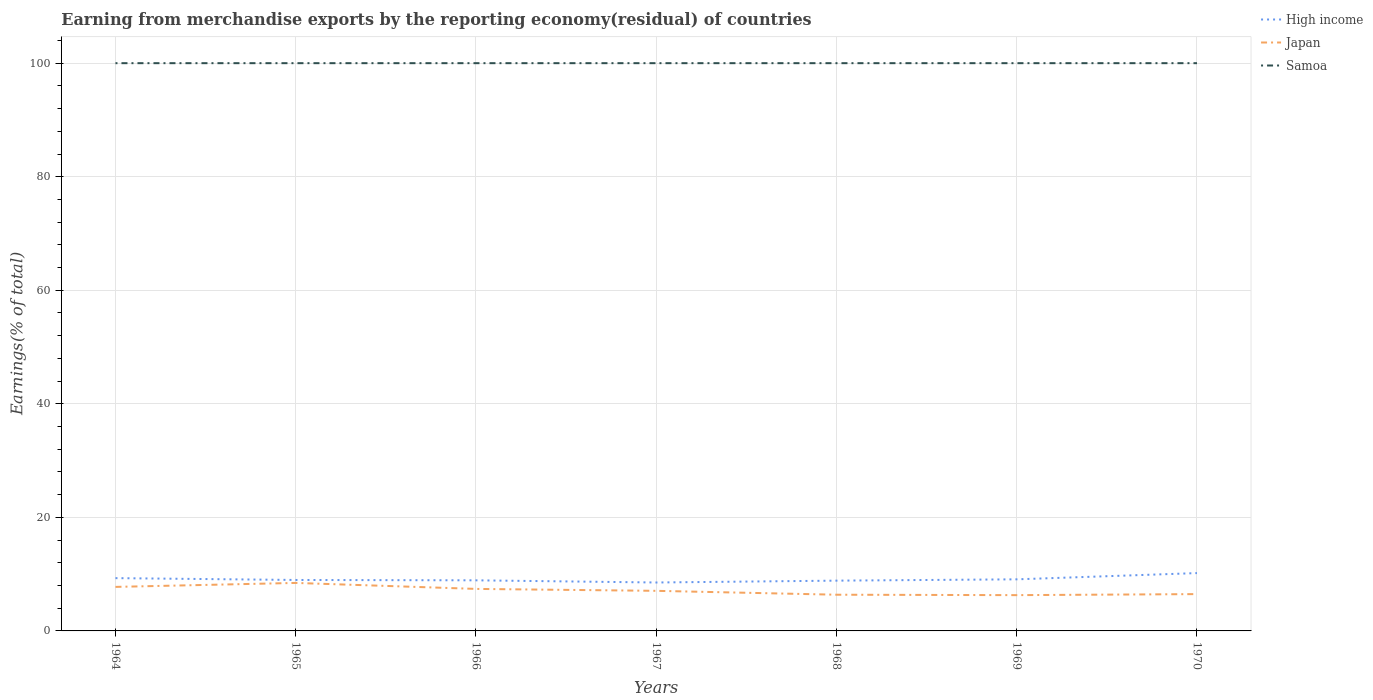How many different coloured lines are there?
Provide a short and direct response. 3. Is the number of lines equal to the number of legend labels?
Your answer should be compact. Yes. In which year was the percentage of amount earned from merchandise exports in Japan maximum?
Provide a succinct answer. 1969. What is the total percentage of amount earned from merchandise exports in High income in the graph?
Provide a succinct answer. -1.27. How many lines are there?
Provide a short and direct response. 3. Are the values on the major ticks of Y-axis written in scientific E-notation?
Ensure brevity in your answer.  No. Does the graph contain any zero values?
Provide a succinct answer. No. How are the legend labels stacked?
Make the answer very short. Vertical. What is the title of the graph?
Keep it short and to the point. Earning from merchandise exports by the reporting economy(residual) of countries. Does "Tunisia" appear as one of the legend labels in the graph?
Your answer should be very brief. No. What is the label or title of the Y-axis?
Provide a succinct answer. Earnings(% of total). What is the Earnings(% of total) of High income in 1964?
Give a very brief answer. 9.3. What is the Earnings(% of total) of Japan in 1964?
Your answer should be compact. 7.75. What is the Earnings(% of total) in High income in 1965?
Give a very brief answer. 8.97. What is the Earnings(% of total) of Japan in 1965?
Provide a succinct answer. 8.45. What is the Earnings(% of total) in High income in 1966?
Offer a very short reply. 8.91. What is the Earnings(% of total) of Japan in 1966?
Keep it short and to the point. 7.4. What is the Earnings(% of total) of Samoa in 1966?
Give a very brief answer. 100. What is the Earnings(% of total) in High income in 1967?
Your response must be concise. 8.53. What is the Earnings(% of total) of Japan in 1967?
Keep it short and to the point. 7.06. What is the Earnings(% of total) of Samoa in 1967?
Ensure brevity in your answer.  100. What is the Earnings(% of total) in High income in 1968?
Your response must be concise. 8.86. What is the Earnings(% of total) in Japan in 1968?
Offer a very short reply. 6.38. What is the Earnings(% of total) of Samoa in 1968?
Give a very brief answer. 100. What is the Earnings(% of total) of High income in 1969?
Ensure brevity in your answer.  9.09. What is the Earnings(% of total) of Japan in 1969?
Offer a very short reply. 6.3. What is the Earnings(% of total) in Samoa in 1969?
Your answer should be compact. 100. What is the Earnings(% of total) of High income in 1970?
Provide a succinct answer. 10.19. What is the Earnings(% of total) in Japan in 1970?
Ensure brevity in your answer.  6.48. What is the Earnings(% of total) of Samoa in 1970?
Your answer should be very brief. 100. Across all years, what is the maximum Earnings(% of total) in High income?
Offer a terse response. 10.19. Across all years, what is the maximum Earnings(% of total) in Japan?
Offer a very short reply. 8.45. Across all years, what is the maximum Earnings(% of total) in Samoa?
Your response must be concise. 100. Across all years, what is the minimum Earnings(% of total) of High income?
Your answer should be very brief. 8.53. Across all years, what is the minimum Earnings(% of total) of Japan?
Provide a short and direct response. 6.3. Across all years, what is the minimum Earnings(% of total) of Samoa?
Offer a terse response. 100. What is the total Earnings(% of total) of High income in the graph?
Offer a terse response. 63.85. What is the total Earnings(% of total) in Japan in the graph?
Provide a short and direct response. 49.83. What is the total Earnings(% of total) of Samoa in the graph?
Your answer should be very brief. 700. What is the difference between the Earnings(% of total) of High income in 1964 and that in 1965?
Make the answer very short. 0.32. What is the difference between the Earnings(% of total) of Japan in 1964 and that in 1965?
Offer a terse response. -0.7. What is the difference between the Earnings(% of total) in High income in 1964 and that in 1966?
Make the answer very short. 0.39. What is the difference between the Earnings(% of total) in Japan in 1964 and that in 1966?
Your response must be concise. 0.35. What is the difference between the Earnings(% of total) of High income in 1964 and that in 1967?
Make the answer very short. 0.77. What is the difference between the Earnings(% of total) in Japan in 1964 and that in 1967?
Keep it short and to the point. 0.69. What is the difference between the Earnings(% of total) in High income in 1964 and that in 1968?
Provide a succinct answer. 0.44. What is the difference between the Earnings(% of total) of Japan in 1964 and that in 1968?
Ensure brevity in your answer.  1.38. What is the difference between the Earnings(% of total) in Samoa in 1964 and that in 1968?
Keep it short and to the point. 0. What is the difference between the Earnings(% of total) of High income in 1964 and that in 1969?
Provide a short and direct response. 0.21. What is the difference between the Earnings(% of total) in Japan in 1964 and that in 1969?
Your answer should be compact. 1.45. What is the difference between the Earnings(% of total) of Samoa in 1964 and that in 1969?
Make the answer very short. 0. What is the difference between the Earnings(% of total) of High income in 1964 and that in 1970?
Keep it short and to the point. -0.89. What is the difference between the Earnings(% of total) in Japan in 1964 and that in 1970?
Your response must be concise. 1.27. What is the difference between the Earnings(% of total) of Samoa in 1964 and that in 1970?
Make the answer very short. 0. What is the difference between the Earnings(% of total) in High income in 1965 and that in 1966?
Provide a short and direct response. 0.06. What is the difference between the Earnings(% of total) of Japan in 1965 and that in 1966?
Give a very brief answer. 1.05. What is the difference between the Earnings(% of total) in High income in 1965 and that in 1967?
Your answer should be very brief. 0.45. What is the difference between the Earnings(% of total) of Japan in 1965 and that in 1967?
Give a very brief answer. 1.39. What is the difference between the Earnings(% of total) of Samoa in 1965 and that in 1967?
Your answer should be compact. 0. What is the difference between the Earnings(% of total) of High income in 1965 and that in 1968?
Make the answer very short. 0.12. What is the difference between the Earnings(% of total) in Japan in 1965 and that in 1968?
Ensure brevity in your answer.  2.08. What is the difference between the Earnings(% of total) in High income in 1965 and that in 1969?
Keep it short and to the point. -0.11. What is the difference between the Earnings(% of total) of Japan in 1965 and that in 1969?
Offer a terse response. 2.15. What is the difference between the Earnings(% of total) of High income in 1965 and that in 1970?
Your answer should be compact. -1.21. What is the difference between the Earnings(% of total) of Japan in 1965 and that in 1970?
Offer a very short reply. 1.97. What is the difference between the Earnings(% of total) of Samoa in 1965 and that in 1970?
Provide a succinct answer. 0. What is the difference between the Earnings(% of total) of High income in 1966 and that in 1967?
Your response must be concise. 0.38. What is the difference between the Earnings(% of total) of Japan in 1966 and that in 1967?
Ensure brevity in your answer.  0.34. What is the difference between the Earnings(% of total) in High income in 1966 and that in 1968?
Your answer should be compact. 0.06. What is the difference between the Earnings(% of total) in Japan in 1966 and that in 1968?
Give a very brief answer. 1.02. What is the difference between the Earnings(% of total) in High income in 1966 and that in 1969?
Keep it short and to the point. -0.17. What is the difference between the Earnings(% of total) in Japan in 1966 and that in 1969?
Offer a terse response. 1.1. What is the difference between the Earnings(% of total) of Samoa in 1966 and that in 1969?
Offer a terse response. 0. What is the difference between the Earnings(% of total) in High income in 1966 and that in 1970?
Your response must be concise. -1.27. What is the difference between the Earnings(% of total) of Japan in 1966 and that in 1970?
Your answer should be very brief. 0.92. What is the difference between the Earnings(% of total) of High income in 1967 and that in 1968?
Your answer should be very brief. -0.33. What is the difference between the Earnings(% of total) in Japan in 1967 and that in 1968?
Make the answer very short. 0.68. What is the difference between the Earnings(% of total) of Samoa in 1967 and that in 1968?
Offer a terse response. 0. What is the difference between the Earnings(% of total) of High income in 1967 and that in 1969?
Your answer should be compact. -0.56. What is the difference between the Earnings(% of total) in Japan in 1967 and that in 1969?
Offer a terse response. 0.76. What is the difference between the Earnings(% of total) in Samoa in 1967 and that in 1969?
Offer a very short reply. 0. What is the difference between the Earnings(% of total) of High income in 1967 and that in 1970?
Offer a terse response. -1.66. What is the difference between the Earnings(% of total) of Japan in 1967 and that in 1970?
Make the answer very short. 0.58. What is the difference between the Earnings(% of total) in High income in 1968 and that in 1969?
Ensure brevity in your answer.  -0.23. What is the difference between the Earnings(% of total) of Japan in 1968 and that in 1969?
Provide a short and direct response. 0.07. What is the difference between the Earnings(% of total) in Samoa in 1968 and that in 1969?
Offer a terse response. 0. What is the difference between the Earnings(% of total) in High income in 1968 and that in 1970?
Provide a short and direct response. -1.33. What is the difference between the Earnings(% of total) in Japan in 1968 and that in 1970?
Your answer should be very brief. -0.11. What is the difference between the Earnings(% of total) in Samoa in 1968 and that in 1970?
Keep it short and to the point. 0. What is the difference between the Earnings(% of total) of High income in 1969 and that in 1970?
Your response must be concise. -1.1. What is the difference between the Earnings(% of total) in Japan in 1969 and that in 1970?
Your answer should be very brief. -0.18. What is the difference between the Earnings(% of total) of Samoa in 1969 and that in 1970?
Make the answer very short. 0. What is the difference between the Earnings(% of total) of High income in 1964 and the Earnings(% of total) of Japan in 1965?
Make the answer very short. 0.84. What is the difference between the Earnings(% of total) in High income in 1964 and the Earnings(% of total) in Samoa in 1965?
Provide a short and direct response. -90.7. What is the difference between the Earnings(% of total) in Japan in 1964 and the Earnings(% of total) in Samoa in 1965?
Your response must be concise. -92.25. What is the difference between the Earnings(% of total) of High income in 1964 and the Earnings(% of total) of Japan in 1966?
Provide a short and direct response. 1.9. What is the difference between the Earnings(% of total) of High income in 1964 and the Earnings(% of total) of Samoa in 1966?
Offer a very short reply. -90.7. What is the difference between the Earnings(% of total) in Japan in 1964 and the Earnings(% of total) in Samoa in 1966?
Provide a short and direct response. -92.25. What is the difference between the Earnings(% of total) in High income in 1964 and the Earnings(% of total) in Japan in 1967?
Offer a very short reply. 2.24. What is the difference between the Earnings(% of total) in High income in 1964 and the Earnings(% of total) in Samoa in 1967?
Make the answer very short. -90.7. What is the difference between the Earnings(% of total) of Japan in 1964 and the Earnings(% of total) of Samoa in 1967?
Your answer should be compact. -92.25. What is the difference between the Earnings(% of total) of High income in 1964 and the Earnings(% of total) of Japan in 1968?
Offer a terse response. 2.92. What is the difference between the Earnings(% of total) in High income in 1964 and the Earnings(% of total) in Samoa in 1968?
Keep it short and to the point. -90.7. What is the difference between the Earnings(% of total) in Japan in 1964 and the Earnings(% of total) in Samoa in 1968?
Offer a terse response. -92.25. What is the difference between the Earnings(% of total) in High income in 1964 and the Earnings(% of total) in Japan in 1969?
Provide a short and direct response. 3. What is the difference between the Earnings(% of total) in High income in 1964 and the Earnings(% of total) in Samoa in 1969?
Ensure brevity in your answer.  -90.7. What is the difference between the Earnings(% of total) of Japan in 1964 and the Earnings(% of total) of Samoa in 1969?
Make the answer very short. -92.25. What is the difference between the Earnings(% of total) of High income in 1964 and the Earnings(% of total) of Japan in 1970?
Keep it short and to the point. 2.81. What is the difference between the Earnings(% of total) in High income in 1964 and the Earnings(% of total) in Samoa in 1970?
Make the answer very short. -90.7. What is the difference between the Earnings(% of total) of Japan in 1964 and the Earnings(% of total) of Samoa in 1970?
Your answer should be very brief. -92.25. What is the difference between the Earnings(% of total) in High income in 1965 and the Earnings(% of total) in Japan in 1966?
Keep it short and to the point. 1.57. What is the difference between the Earnings(% of total) of High income in 1965 and the Earnings(% of total) of Samoa in 1966?
Provide a short and direct response. -91.03. What is the difference between the Earnings(% of total) in Japan in 1965 and the Earnings(% of total) in Samoa in 1966?
Keep it short and to the point. -91.55. What is the difference between the Earnings(% of total) in High income in 1965 and the Earnings(% of total) in Japan in 1967?
Your response must be concise. 1.91. What is the difference between the Earnings(% of total) of High income in 1965 and the Earnings(% of total) of Samoa in 1967?
Your answer should be compact. -91.03. What is the difference between the Earnings(% of total) in Japan in 1965 and the Earnings(% of total) in Samoa in 1967?
Make the answer very short. -91.55. What is the difference between the Earnings(% of total) in High income in 1965 and the Earnings(% of total) in Japan in 1968?
Offer a terse response. 2.6. What is the difference between the Earnings(% of total) of High income in 1965 and the Earnings(% of total) of Samoa in 1968?
Make the answer very short. -91.03. What is the difference between the Earnings(% of total) in Japan in 1965 and the Earnings(% of total) in Samoa in 1968?
Give a very brief answer. -91.55. What is the difference between the Earnings(% of total) of High income in 1965 and the Earnings(% of total) of Japan in 1969?
Give a very brief answer. 2.67. What is the difference between the Earnings(% of total) of High income in 1965 and the Earnings(% of total) of Samoa in 1969?
Offer a terse response. -91.03. What is the difference between the Earnings(% of total) in Japan in 1965 and the Earnings(% of total) in Samoa in 1969?
Offer a terse response. -91.55. What is the difference between the Earnings(% of total) in High income in 1965 and the Earnings(% of total) in Japan in 1970?
Ensure brevity in your answer.  2.49. What is the difference between the Earnings(% of total) in High income in 1965 and the Earnings(% of total) in Samoa in 1970?
Your answer should be very brief. -91.03. What is the difference between the Earnings(% of total) in Japan in 1965 and the Earnings(% of total) in Samoa in 1970?
Your response must be concise. -91.55. What is the difference between the Earnings(% of total) of High income in 1966 and the Earnings(% of total) of Japan in 1967?
Keep it short and to the point. 1.85. What is the difference between the Earnings(% of total) of High income in 1966 and the Earnings(% of total) of Samoa in 1967?
Keep it short and to the point. -91.09. What is the difference between the Earnings(% of total) of Japan in 1966 and the Earnings(% of total) of Samoa in 1967?
Keep it short and to the point. -92.6. What is the difference between the Earnings(% of total) of High income in 1966 and the Earnings(% of total) of Japan in 1968?
Provide a succinct answer. 2.54. What is the difference between the Earnings(% of total) of High income in 1966 and the Earnings(% of total) of Samoa in 1968?
Give a very brief answer. -91.09. What is the difference between the Earnings(% of total) in Japan in 1966 and the Earnings(% of total) in Samoa in 1968?
Offer a terse response. -92.6. What is the difference between the Earnings(% of total) in High income in 1966 and the Earnings(% of total) in Japan in 1969?
Your response must be concise. 2.61. What is the difference between the Earnings(% of total) in High income in 1966 and the Earnings(% of total) in Samoa in 1969?
Offer a very short reply. -91.09. What is the difference between the Earnings(% of total) in Japan in 1966 and the Earnings(% of total) in Samoa in 1969?
Your answer should be very brief. -92.6. What is the difference between the Earnings(% of total) in High income in 1966 and the Earnings(% of total) in Japan in 1970?
Provide a succinct answer. 2.43. What is the difference between the Earnings(% of total) of High income in 1966 and the Earnings(% of total) of Samoa in 1970?
Provide a succinct answer. -91.09. What is the difference between the Earnings(% of total) in Japan in 1966 and the Earnings(% of total) in Samoa in 1970?
Make the answer very short. -92.6. What is the difference between the Earnings(% of total) in High income in 1967 and the Earnings(% of total) in Japan in 1968?
Your response must be concise. 2.15. What is the difference between the Earnings(% of total) of High income in 1967 and the Earnings(% of total) of Samoa in 1968?
Your answer should be very brief. -91.47. What is the difference between the Earnings(% of total) of Japan in 1967 and the Earnings(% of total) of Samoa in 1968?
Give a very brief answer. -92.94. What is the difference between the Earnings(% of total) of High income in 1967 and the Earnings(% of total) of Japan in 1969?
Your answer should be very brief. 2.23. What is the difference between the Earnings(% of total) in High income in 1967 and the Earnings(% of total) in Samoa in 1969?
Provide a succinct answer. -91.47. What is the difference between the Earnings(% of total) of Japan in 1967 and the Earnings(% of total) of Samoa in 1969?
Provide a short and direct response. -92.94. What is the difference between the Earnings(% of total) in High income in 1967 and the Earnings(% of total) in Japan in 1970?
Keep it short and to the point. 2.05. What is the difference between the Earnings(% of total) in High income in 1967 and the Earnings(% of total) in Samoa in 1970?
Offer a terse response. -91.47. What is the difference between the Earnings(% of total) of Japan in 1967 and the Earnings(% of total) of Samoa in 1970?
Your answer should be very brief. -92.94. What is the difference between the Earnings(% of total) of High income in 1968 and the Earnings(% of total) of Japan in 1969?
Your answer should be compact. 2.55. What is the difference between the Earnings(% of total) of High income in 1968 and the Earnings(% of total) of Samoa in 1969?
Make the answer very short. -91.14. What is the difference between the Earnings(% of total) in Japan in 1968 and the Earnings(% of total) in Samoa in 1969?
Your response must be concise. -93.62. What is the difference between the Earnings(% of total) in High income in 1968 and the Earnings(% of total) in Japan in 1970?
Your answer should be compact. 2.37. What is the difference between the Earnings(% of total) of High income in 1968 and the Earnings(% of total) of Samoa in 1970?
Offer a terse response. -91.14. What is the difference between the Earnings(% of total) in Japan in 1968 and the Earnings(% of total) in Samoa in 1970?
Offer a terse response. -93.62. What is the difference between the Earnings(% of total) in High income in 1969 and the Earnings(% of total) in Japan in 1970?
Offer a very short reply. 2.6. What is the difference between the Earnings(% of total) of High income in 1969 and the Earnings(% of total) of Samoa in 1970?
Keep it short and to the point. -90.91. What is the difference between the Earnings(% of total) in Japan in 1969 and the Earnings(% of total) in Samoa in 1970?
Ensure brevity in your answer.  -93.7. What is the average Earnings(% of total) in High income per year?
Provide a succinct answer. 9.12. What is the average Earnings(% of total) in Japan per year?
Your response must be concise. 7.12. What is the average Earnings(% of total) in Samoa per year?
Your answer should be compact. 100. In the year 1964, what is the difference between the Earnings(% of total) in High income and Earnings(% of total) in Japan?
Your response must be concise. 1.54. In the year 1964, what is the difference between the Earnings(% of total) of High income and Earnings(% of total) of Samoa?
Ensure brevity in your answer.  -90.7. In the year 1964, what is the difference between the Earnings(% of total) of Japan and Earnings(% of total) of Samoa?
Ensure brevity in your answer.  -92.25. In the year 1965, what is the difference between the Earnings(% of total) in High income and Earnings(% of total) in Japan?
Offer a very short reply. 0.52. In the year 1965, what is the difference between the Earnings(% of total) of High income and Earnings(% of total) of Samoa?
Provide a succinct answer. -91.03. In the year 1965, what is the difference between the Earnings(% of total) in Japan and Earnings(% of total) in Samoa?
Provide a succinct answer. -91.55. In the year 1966, what is the difference between the Earnings(% of total) of High income and Earnings(% of total) of Japan?
Give a very brief answer. 1.51. In the year 1966, what is the difference between the Earnings(% of total) of High income and Earnings(% of total) of Samoa?
Your answer should be compact. -91.09. In the year 1966, what is the difference between the Earnings(% of total) of Japan and Earnings(% of total) of Samoa?
Provide a succinct answer. -92.6. In the year 1967, what is the difference between the Earnings(% of total) of High income and Earnings(% of total) of Japan?
Give a very brief answer. 1.47. In the year 1967, what is the difference between the Earnings(% of total) in High income and Earnings(% of total) in Samoa?
Provide a short and direct response. -91.47. In the year 1967, what is the difference between the Earnings(% of total) of Japan and Earnings(% of total) of Samoa?
Ensure brevity in your answer.  -92.94. In the year 1968, what is the difference between the Earnings(% of total) in High income and Earnings(% of total) in Japan?
Your answer should be compact. 2.48. In the year 1968, what is the difference between the Earnings(% of total) of High income and Earnings(% of total) of Samoa?
Provide a succinct answer. -91.14. In the year 1968, what is the difference between the Earnings(% of total) in Japan and Earnings(% of total) in Samoa?
Ensure brevity in your answer.  -93.62. In the year 1969, what is the difference between the Earnings(% of total) in High income and Earnings(% of total) in Japan?
Offer a terse response. 2.78. In the year 1969, what is the difference between the Earnings(% of total) in High income and Earnings(% of total) in Samoa?
Offer a terse response. -90.91. In the year 1969, what is the difference between the Earnings(% of total) of Japan and Earnings(% of total) of Samoa?
Give a very brief answer. -93.7. In the year 1970, what is the difference between the Earnings(% of total) in High income and Earnings(% of total) in Japan?
Provide a succinct answer. 3.7. In the year 1970, what is the difference between the Earnings(% of total) of High income and Earnings(% of total) of Samoa?
Offer a very short reply. -89.81. In the year 1970, what is the difference between the Earnings(% of total) in Japan and Earnings(% of total) in Samoa?
Offer a very short reply. -93.52. What is the ratio of the Earnings(% of total) in High income in 1964 to that in 1965?
Provide a succinct answer. 1.04. What is the ratio of the Earnings(% of total) of Japan in 1964 to that in 1965?
Your response must be concise. 0.92. What is the ratio of the Earnings(% of total) in High income in 1964 to that in 1966?
Provide a succinct answer. 1.04. What is the ratio of the Earnings(% of total) in Japan in 1964 to that in 1966?
Your answer should be compact. 1.05. What is the ratio of the Earnings(% of total) in Samoa in 1964 to that in 1966?
Give a very brief answer. 1. What is the ratio of the Earnings(% of total) in High income in 1964 to that in 1967?
Offer a very short reply. 1.09. What is the ratio of the Earnings(% of total) of Japan in 1964 to that in 1967?
Provide a succinct answer. 1.1. What is the ratio of the Earnings(% of total) of Samoa in 1964 to that in 1967?
Make the answer very short. 1. What is the ratio of the Earnings(% of total) in Japan in 1964 to that in 1968?
Ensure brevity in your answer.  1.22. What is the ratio of the Earnings(% of total) of High income in 1964 to that in 1969?
Offer a very short reply. 1.02. What is the ratio of the Earnings(% of total) in Japan in 1964 to that in 1969?
Provide a succinct answer. 1.23. What is the ratio of the Earnings(% of total) in High income in 1964 to that in 1970?
Provide a succinct answer. 0.91. What is the ratio of the Earnings(% of total) of Japan in 1964 to that in 1970?
Your answer should be compact. 1.2. What is the ratio of the Earnings(% of total) in Samoa in 1964 to that in 1970?
Your answer should be compact. 1. What is the ratio of the Earnings(% of total) of Japan in 1965 to that in 1966?
Provide a succinct answer. 1.14. What is the ratio of the Earnings(% of total) of High income in 1965 to that in 1967?
Offer a terse response. 1.05. What is the ratio of the Earnings(% of total) in Japan in 1965 to that in 1967?
Give a very brief answer. 1.2. What is the ratio of the Earnings(% of total) of High income in 1965 to that in 1968?
Offer a very short reply. 1.01. What is the ratio of the Earnings(% of total) in Japan in 1965 to that in 1968?
Ensure brevity in your answer.  1.33. What is the ratio of the Earnings(% of total) of Samoa in 1965 to that in 1968?
Give a very brief answer. 1. What is the ratio of the Earnings(% of total) in Japan in 1965 to that in 1969?
Give a very brief answer. 1.34. What is the ratio of the Earnings(% of total) of Samoa in 1965 to that in 1969?
Keep it short and to the point. 1. What is the ratio of the Earnings(% of total) of High income in 1965 to that in 1970?
Offer a very short reply. 0.88. What is the ratio of the Earnings(% of total) in Japan in 1965 to that in 1970?
Make the answer very short. 1.3. What is the ratio of the Earnings(% of total) in Samoa in 1965 to that in 1970?
Offer a terse response. 1. What is the ratio of the Earnings(% of total) of High income in 1966 to that in 1967?
Keep it short and to the point. 1.04. What is the ratio of the Earnings(% of total) in Japan in 1966 to that in 1967?
Offer a terse response. 1.05. What is the ratio of the Earnings(% of total) of Samoa in 1966 to that in 1967?
Make the answer very short. 1. What is the ratio of the Earnings(% of total) in High income in 1966 to that in 1968?
Provide a succinct answer. 1.01. What is the ratio of the Earnings(% of total) of Japan in 1966 to that in 1968?
Keep it short and to the point. 1.16. What is the ratio of the Earnings(% of total) of High income in 1966 to that in 1969?
Offer a terse response. 0.98. What is the ratio of the Earnings(% of total) of Japan in 1966 to that in 1969?
Your answer should be compact. 1.17. What is the ratio of the Earnings(% of total) in Samoa in 1966 to that in 1969?
Ensure brevity in your answer.  1. What is the ratio of the Earnings(% of total) of High income in 1966 to that in 1970?
Your answer should be compact. 0.87. What is the ratio of the Earnings(% of total) in Japan in 1966 to that in 1970?
Your answer should be compact. 1.14. What is the ratio of the Earnings(% of total) of High income in 1967 to that in 1968?
Your answer should be compact. 0.96. What is the ratio of the Earnings(% of total) of Japan in 1967 to that in 1968?
Provide a short and direct response. 1.11. What is the ratio of the Earnings(% of total) of Samoa in 1967 to that in 1968?
Offer a very short reply. 1. What is the ratio of the Earnings(% of total) in High income in 1967 to that in 1969?
Keep it short and to the point. 0.94. What is the ratio of the Earnings(% of total) of Japan in 1967 to that in 1969?
Your answer should be very brief. 1.12. What is the ratio of the Earnings(% of total) of High income in 1967 to that in 1970?
Your answer should be very brief. 0.84. What is the ratio of the Earnings(% of total) of Japan in 1967 to that in 1970?
Your response must be concise. 1.09. What is the ratio of the Earnings(% of total) in Samoa in 1967 to that in 1970?
Your response must be concise. 1. What is the ratio of the Earnings(% of total) in High income in 1968 to that in 1969?
Your answer should be very brief. 0.97. What is the ratio of the Earnings(% of total) of Japan in 1968 to that in 1969?
Provide a short and direct response. 1.01. What is the ratio of the Earnings(% of total) in High income in 1968 to that in 1970?
Provide a short and direct response. 0.87. What is the ratio of the Earnings(% of total) in Japan in 1968 to that in 1970?
Your response must be concise. 0.98. What is the ratio of the Earnings(% of total) of High income in 1969 to that in 1970?
Your answer should be very brief. 0.89. What is the ratio of the Earnings(% of total) in Japan in 1969 to that in 1970?
Provide a succinct answer. 0.97. What is the difference between the highest and the second highest Earnings(% of total) in High income?
Offer a terse response. 0.89. What is the difference between the highest and the second highest Earnings(% of total) in Japan?
Offer a very short reply. 0.7. What is the difference between the highest and the lowest Earnings(% of total) of High income?
Make the answer very short. 1.66. What is the difference between the highest and the lowest Earnings(% of total) in Japan?
Provide a short and direct response. 2.15. 